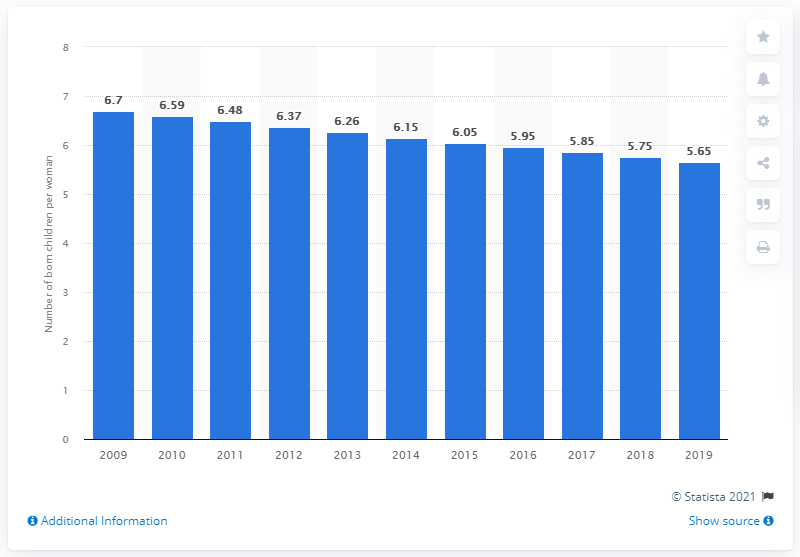Draw attention to some important aspects in this diagram. In 2019, the fertility rate in Chad was 5.65. 